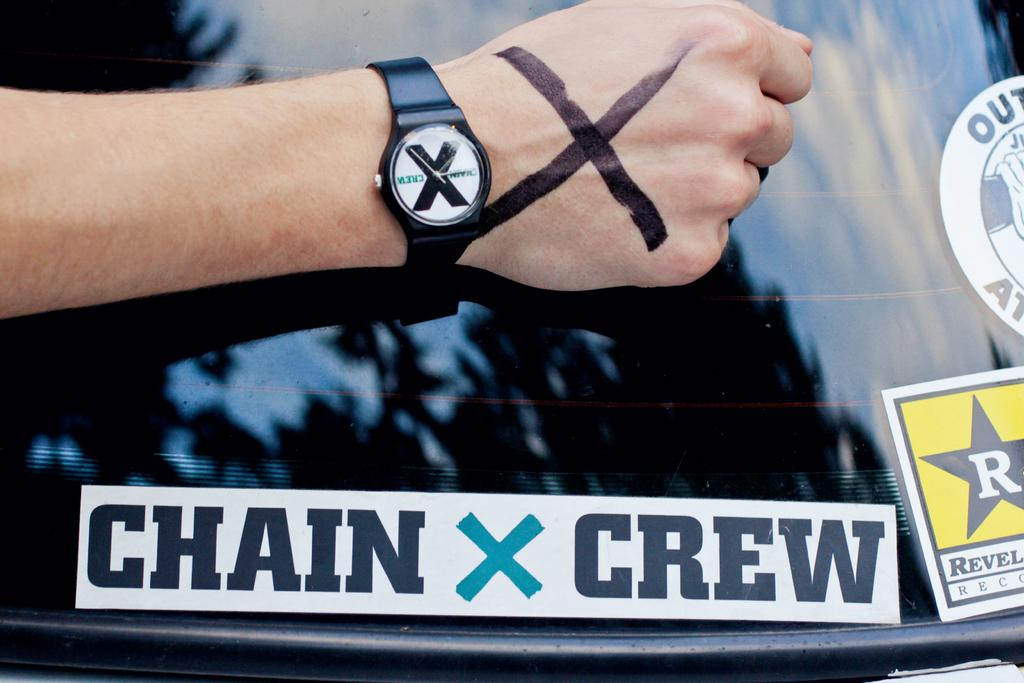<image>
Summarize the visual content of the image. Person wearing a watch placing their arm above a "Chain X Crew" sticker. 